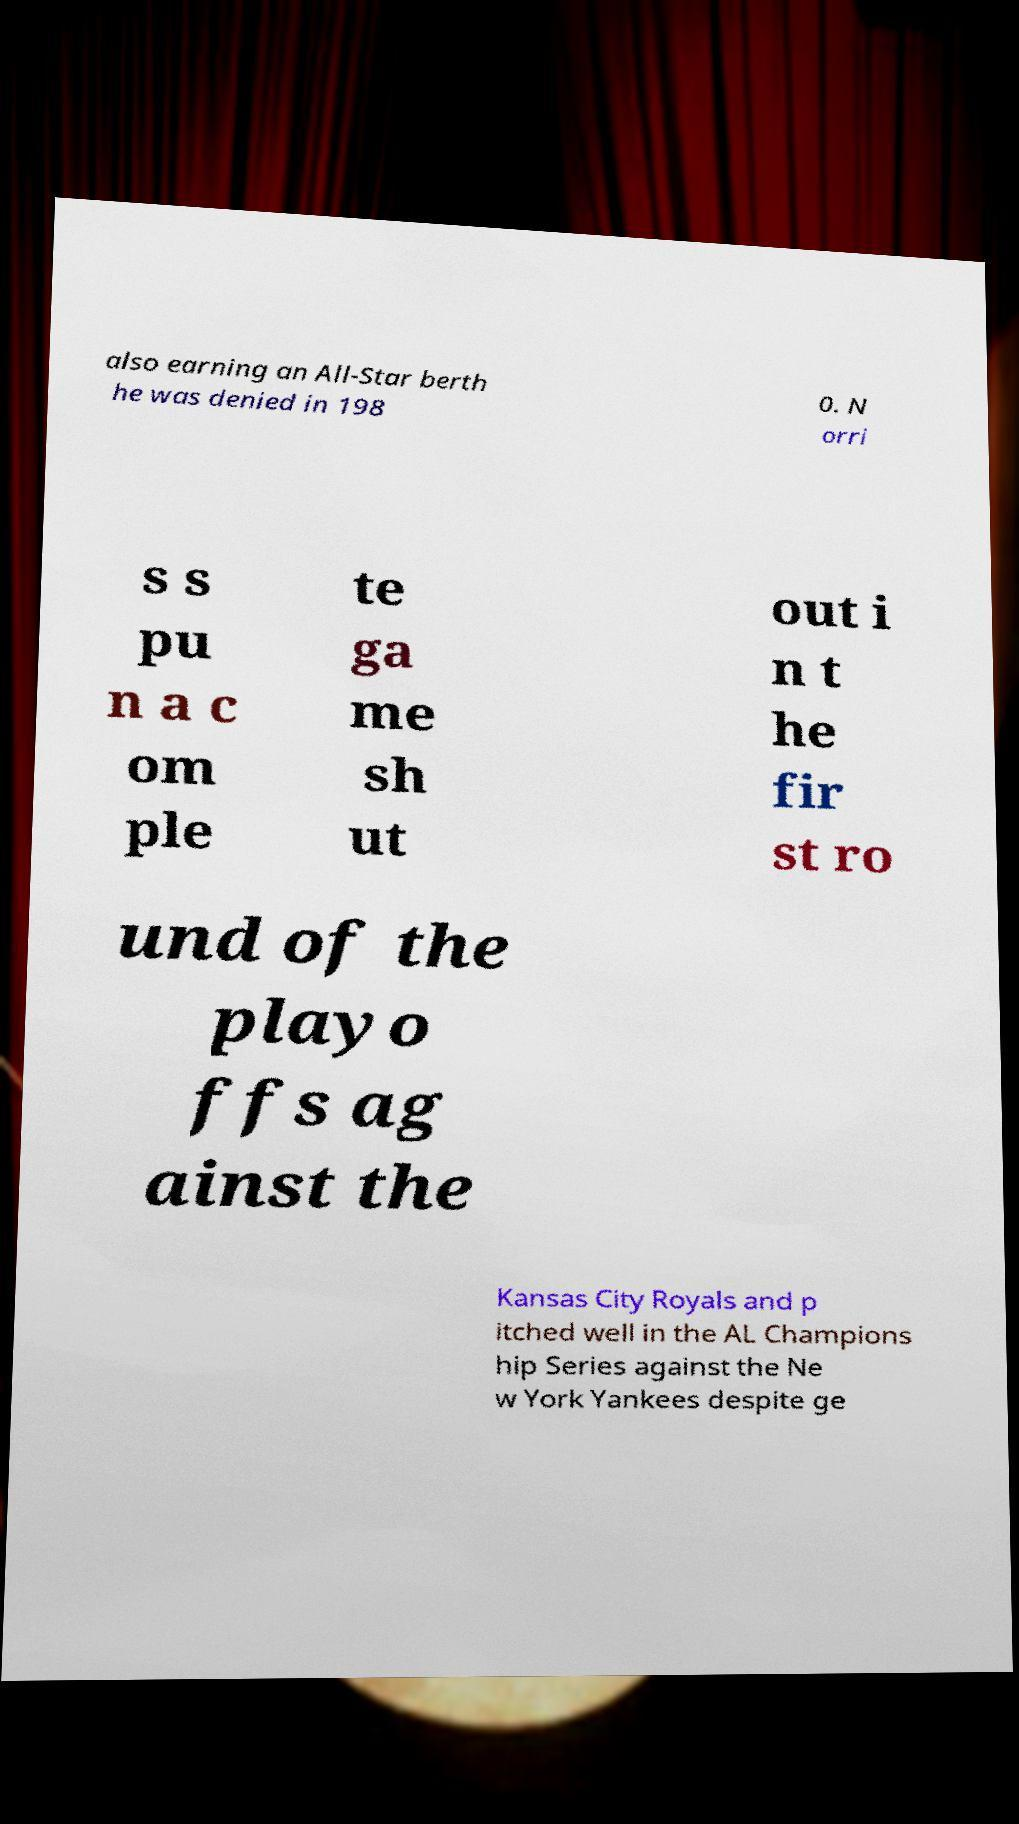I need the written content from this picture converted into text. Can you do that? also earning an All-Star berth he was denied in 198 0. N orri s s pu n a c om ple te ga me sh ut out i n t he fir st ro und of the playo ffs ag ainst the Kansas City Royals and p itched well in the AL Champions hip Series against the Ne w York Yankees despite ge 